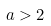<formula> <loc_0><loc_0><loc_500><loc_500>a > 2</formula> 